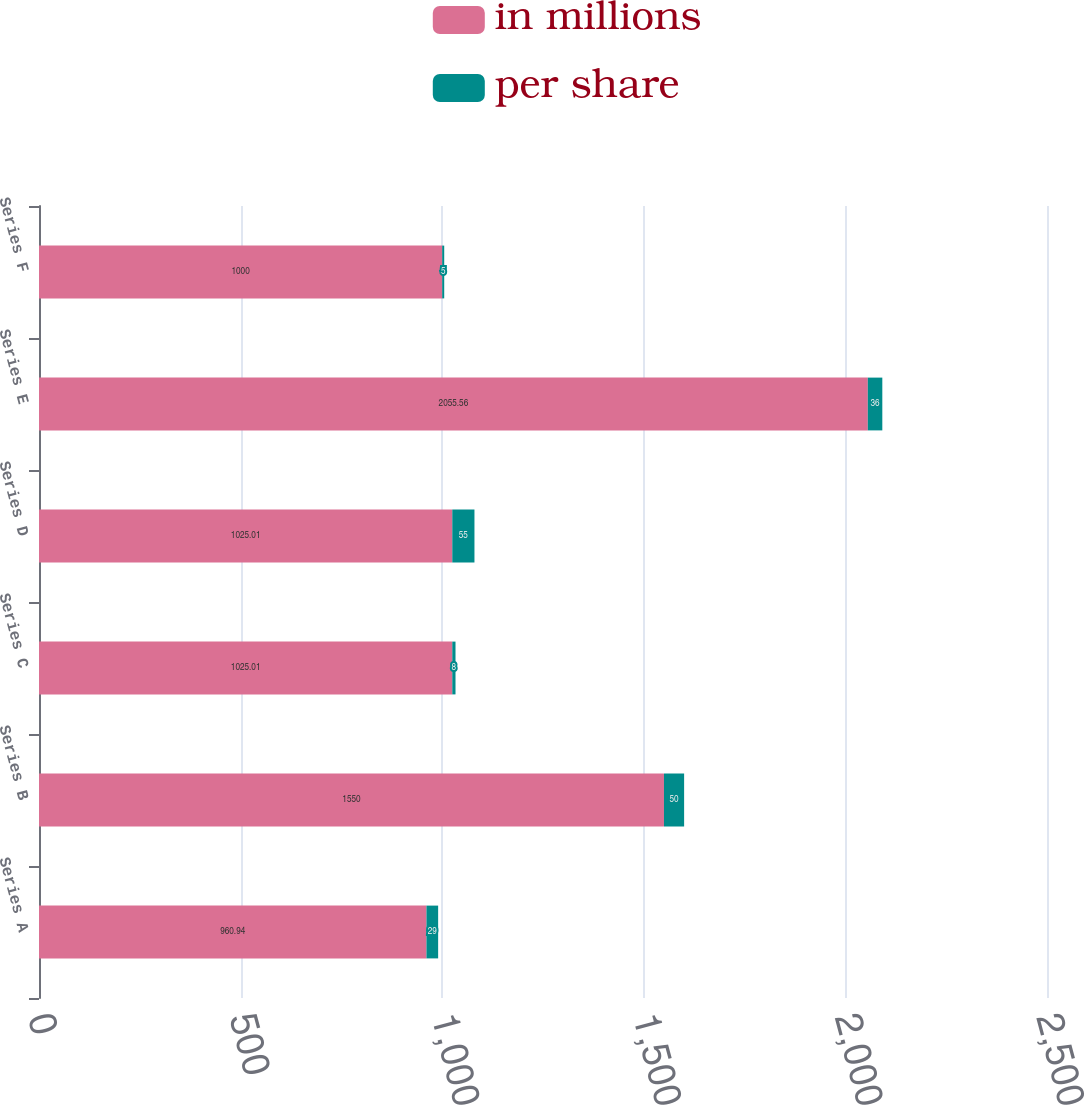<chart> <loc_0><loc_0><loc_500><loc_500><stacked_bar_chart><ecel><fcel>Series A<fcel>Series B<fcel>Series C<fcel>Series D<fcel>Series E<fcel>Series F<nl><fcel>in millions<fcel>960.94<fcel>1550<fcel>1025.01<fcel>1025.01<fcel>2055.56<fcel>1000<nl><fcel>per share<fcel>29<fcel>50<fcel>8<fcel>55<fcel>36<fcel>5<nl></chart> 